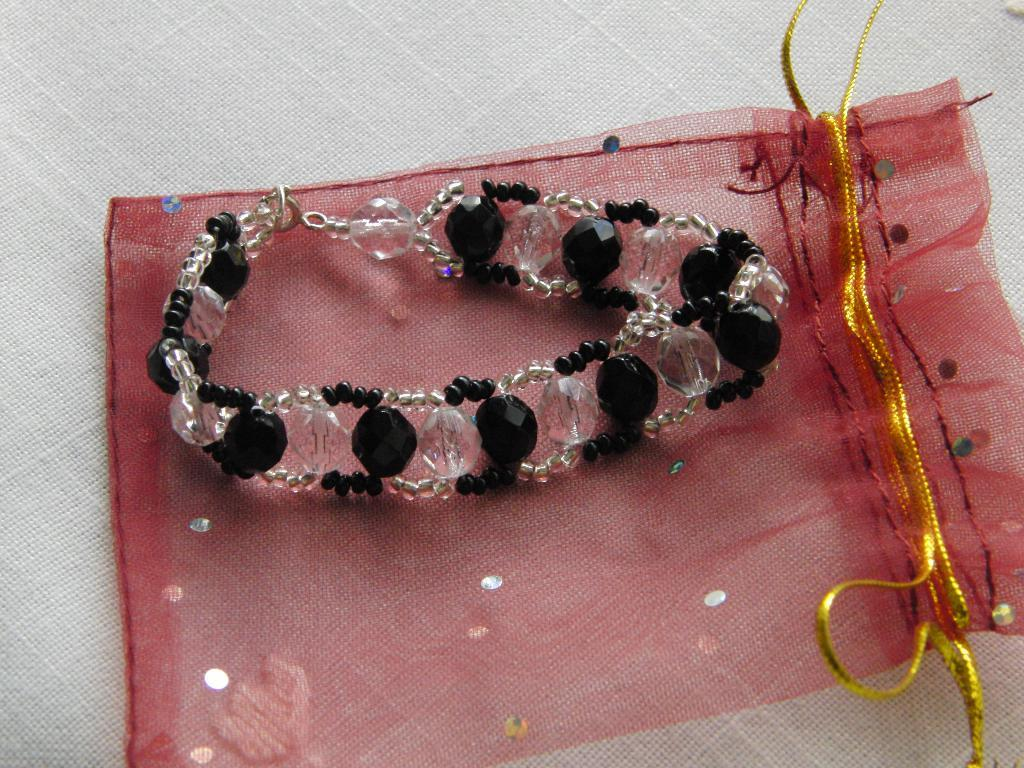What type of accessory is present in the image? There is a bracelet in the image. What else is present in the image besides the bracelet? There is a cover in the image. Where are the bracelet and cover placed? The bracelet and cover are placed on a cloth. What type of beam can be seen supporting the ceiling in the image? There is no beam visible in the image; it only shows a bracelet, cover, and cloth. 